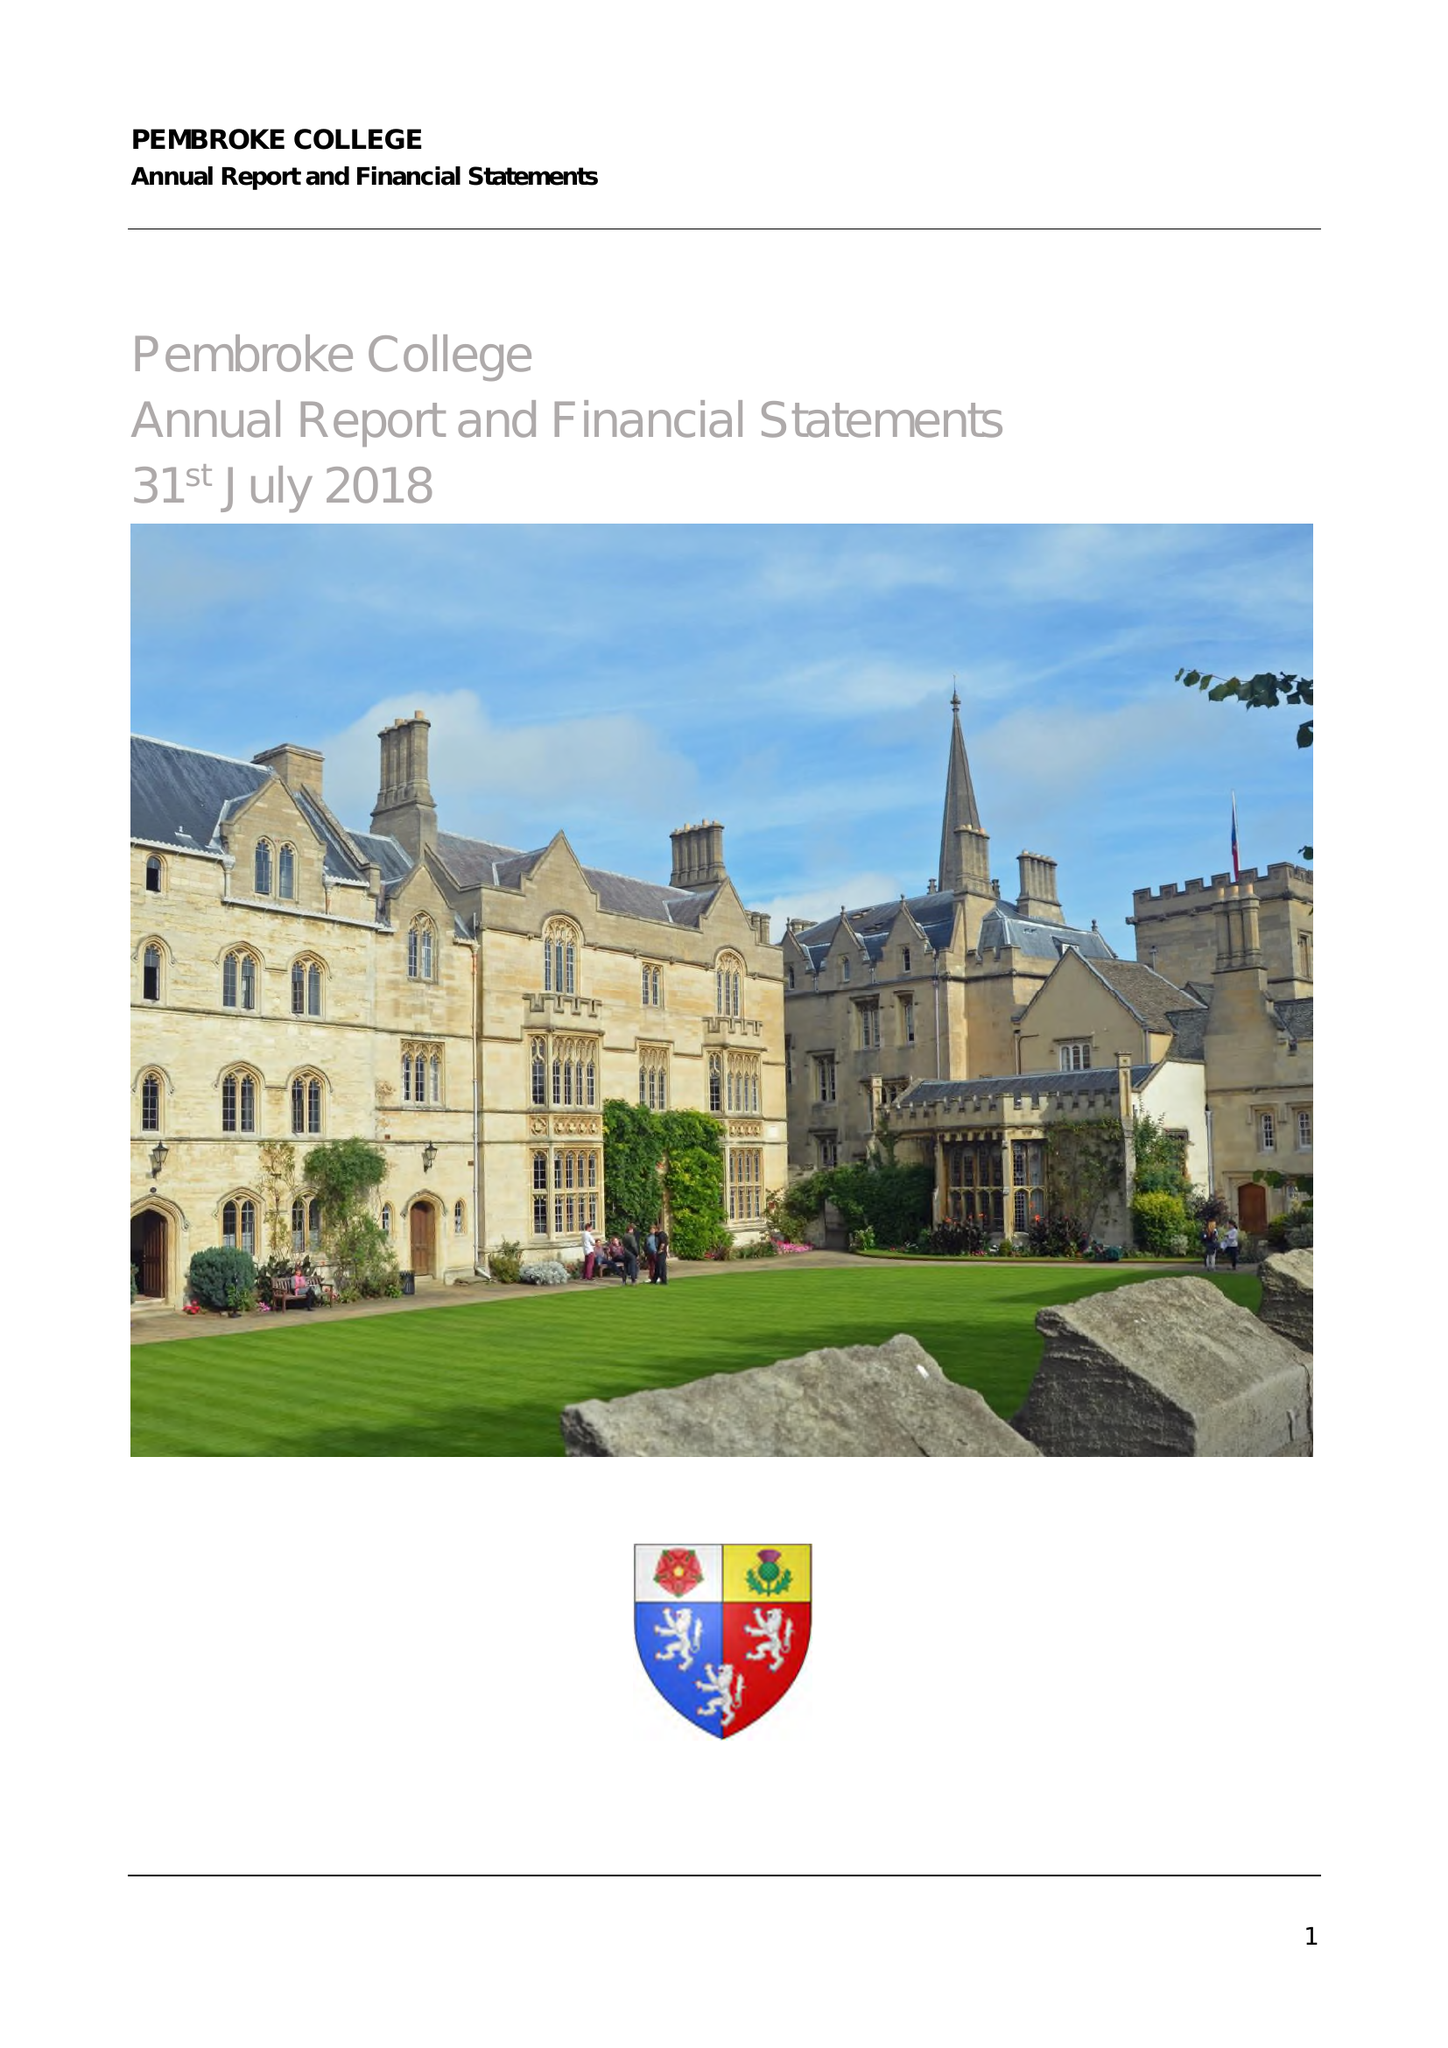What is the value for the report_date?
Answer the question using a single word or phrase. 2018-07-31 